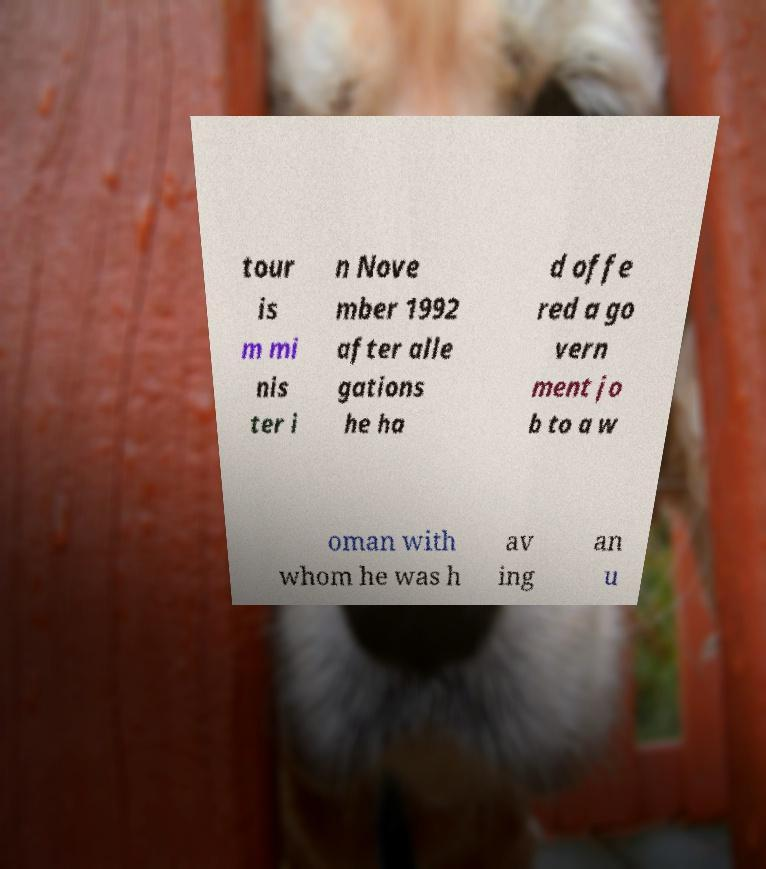For documentation purposes, I need the text within this image transcribed. Could you provide that? tour is m mi nis ter i n Nove mber 1992 after alle gations he ha d offe red a go vern ment jo b to a w oman with whom he was h av ing an u 